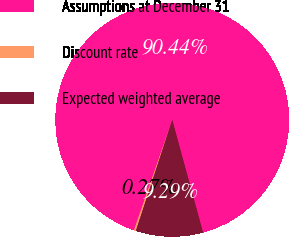Convert chart. <chart><loc_0><loc_0><loc_500><loc_500><pie_chart><fcel>Assumptions at December 31<fcel>Discount rate<fcel>Expected weighted average<nl><fcel>90.44%<fcel>0.27%<fcel>9.29%<nl></chart> 